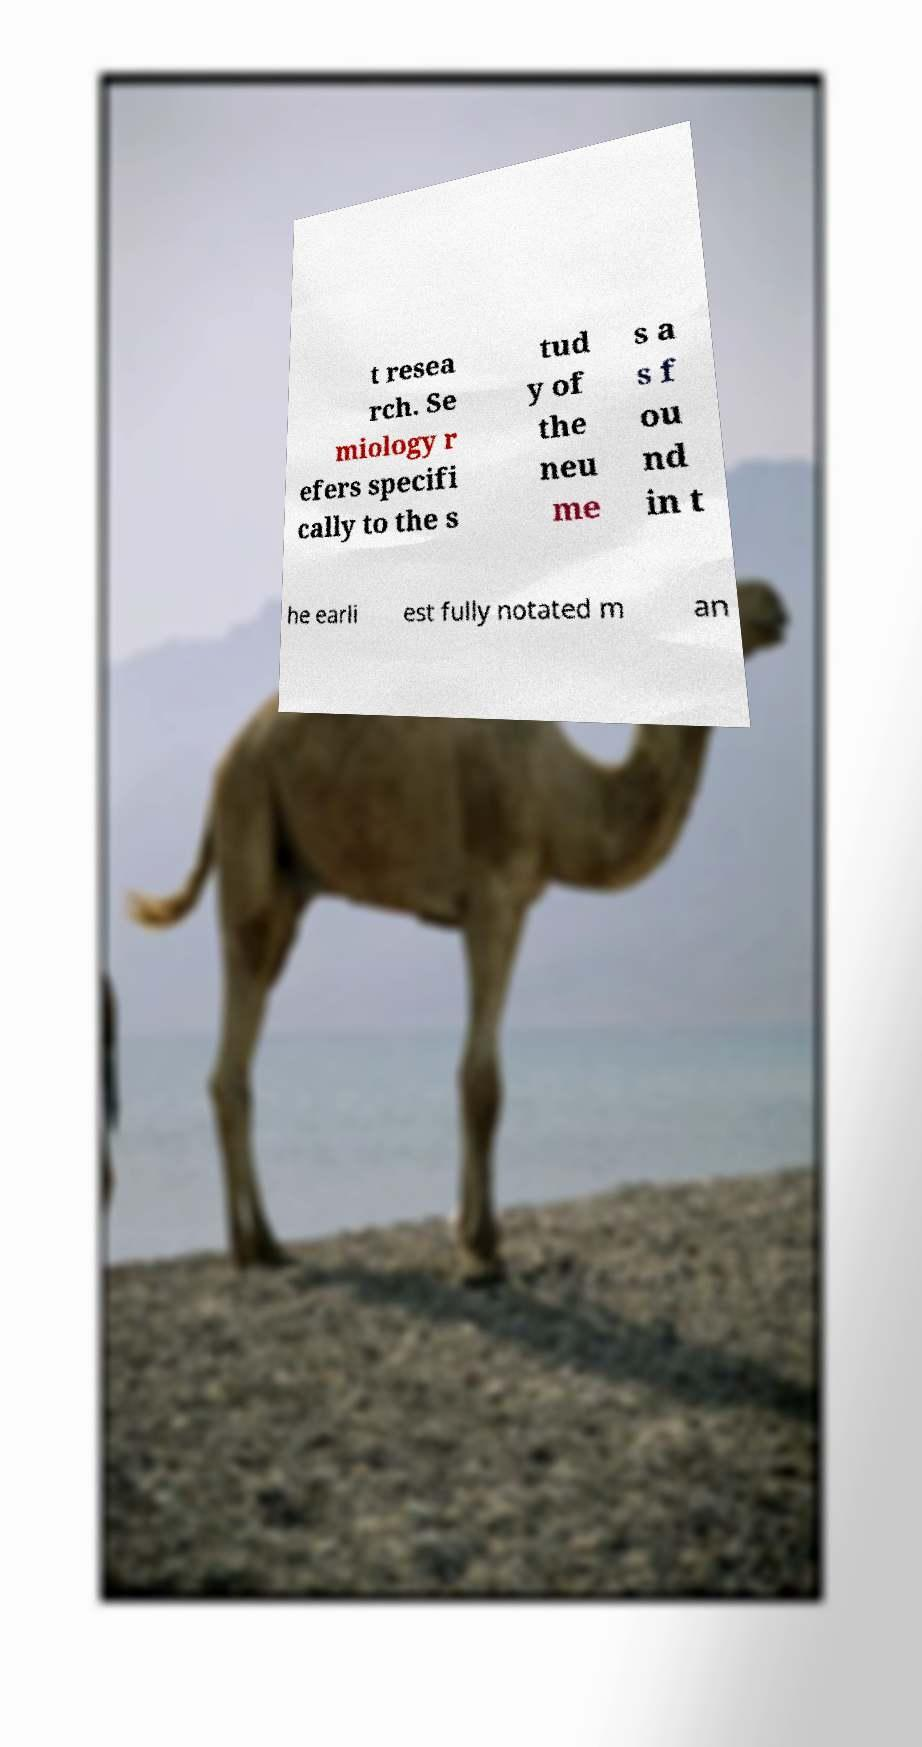Could you extract and type out the text from this image? t resea rch. Se miology r efers specifi cally to the s tud y of the neu me s a s f ou nd in t he earli est fully notated m an 